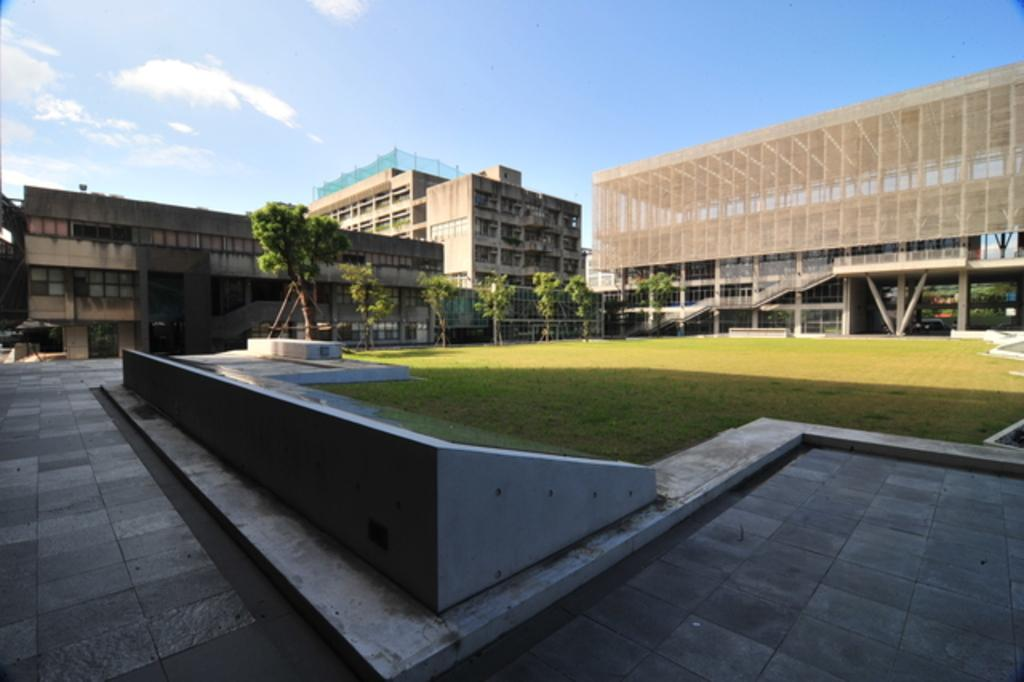What type of surface is visible in the image? There is ground visible in the image. What type of vegetation can be seen in the image? There is grass in the image. What type of natural structures are present in the image? There are trees in the image. What type of man-made structures are present in the image? There are buildings in the image. What is visible in the background of the image? The sky is visible in the background of the image. What type of stew is being prepared in the image? There is no stew present in the image; it features natural and man-made structures, as well as vegetation and the sky. 